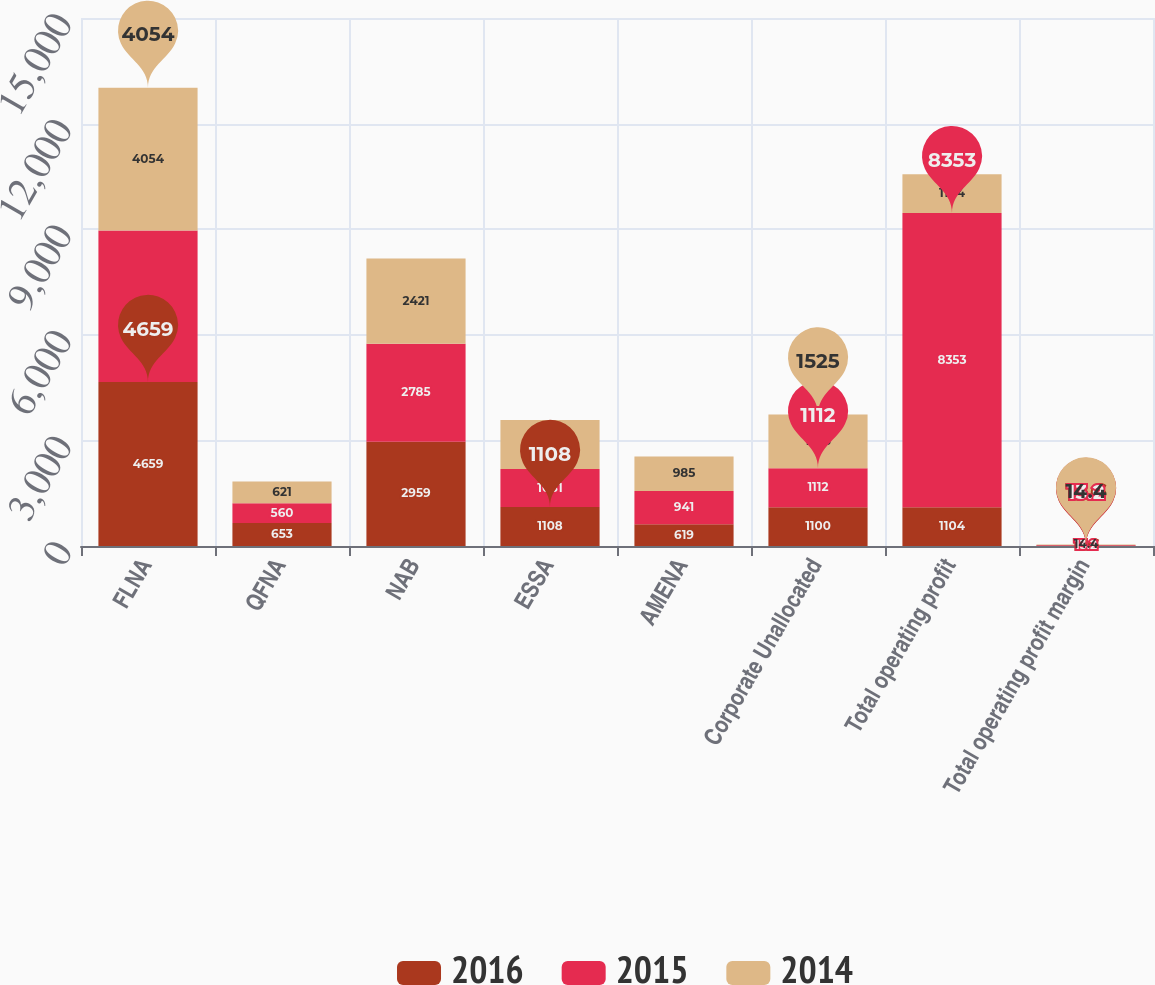Convert chart to OTSL. <chart><loc_0><loc_0><loc_500><loc_500><stacked_bar_chart><ecel><fcel>FLNA<fcel>QFNA<fcel>NAB<fcel>ESSA<fcel>AMENA<fcel>Corporate Unallocated<fcel>Total operating profit<fcel>Total operating profit margin<nl><fcel>2016<fcel>4659<fcel>653<fcel>2959<fcel>1108<fcel>619<fcel>1100<fcel>1104<fcel>15.6<nl><fcel>2015<fcel>4304<fcel>560<fcel>2785<fcel>1081<fcel>941<fcel>1112<fcel>8353<fcel>13.2<nl><fcel>2014<fcel>4054<fcel>621<fcel>2421<fcel>1389<fcel>985<fcel>1525<fcel>1104<fcel>14.4<nl></chart> 